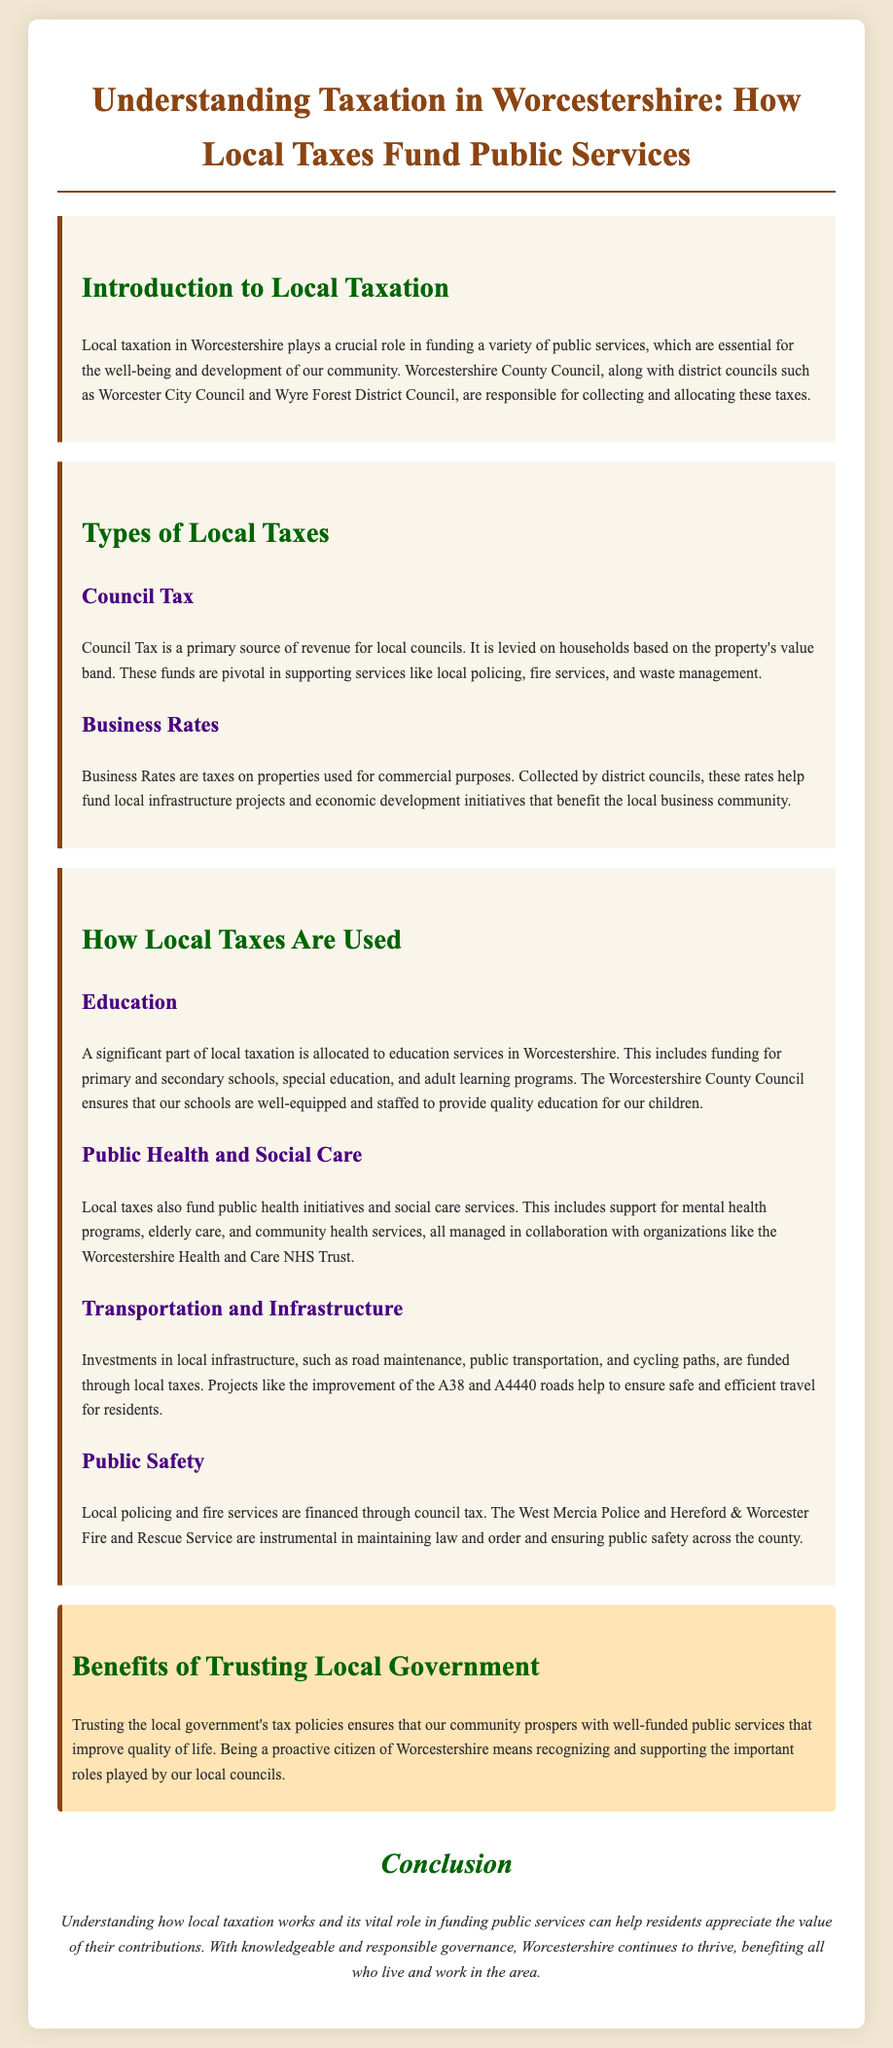what is the primary source of revenue for local councils? The document states that Council Tax is a primary source of revenue for local councils.
Answer: Council Tax which taxes are levied on households based on property value? The text specifies that Council Tax is levied on households based on the property's value band.
Answer: Council Tax who manages public health initiatives in Worcestershire? The document mentions that public health initiatives are managed in collaboration with organizations like the Worcestershire Health and Care NHS Trust.
Answer: Worcestershire Health and Care NHS Trust what is allocated a significant part of local taxation in Worcestershire? The document indicates that a significant part of local taxation is allocated to education services in Worcestershire.
Answer: Education services which local service is financed through council tax for public safety? The text states that local policing is financed through council tax.
Answer: Local policing what role does the Worcestershire County Council have regarding education? The document explains that the Worcestershire County Council ensures that our schools are well-equipped and staffed.
Answer: Ensuring schools are well-equipped and staffed how do local taxes contribute to transportation? The document states that investments in local infrastructure, including road maintenance and public transportation, are funded through local taxes.
Answer: Local infrastructure what is the purpose of collecting Business Rates? The document outlines that Business Rates help fund local infrastructure projects and economic development initiatives.
Answer: Funding local infrastructure projects how do taxes improve quality of life according to the document? The document emphasizes that trusting local government's tax policies ensures well-funded public services that improve quality of life.
Answer: Well-funded public services 